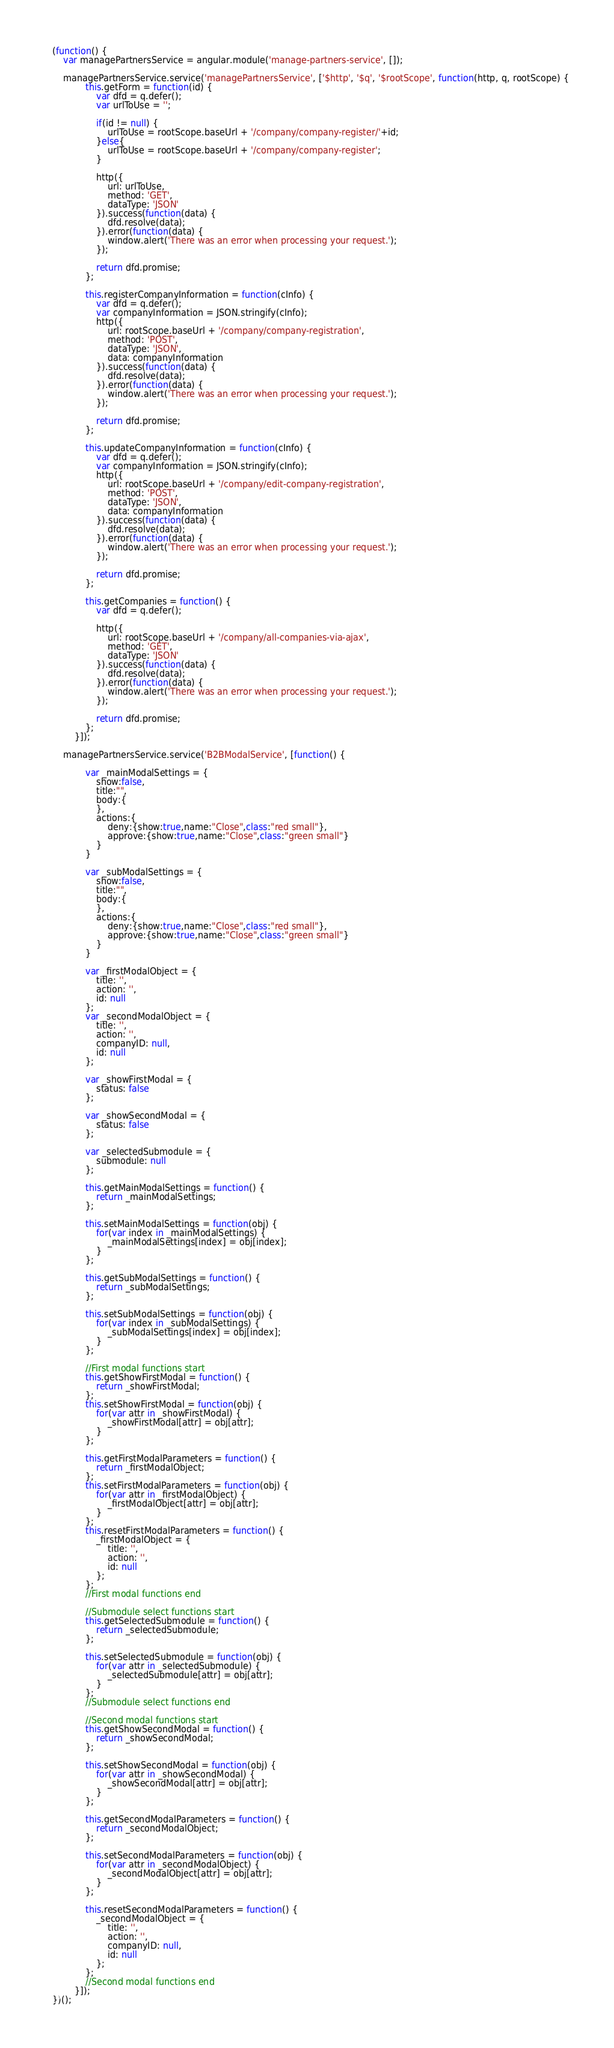Convert code to text. <code><loc_0><loc_0><loc_500><loc_500><_JavaScript_>(function() {
    var managePartnersService = angular.module('manage-partners-service', []);

    managePartnersService.service('managePartnersService', ['$http', '$q', '$rootScope', function(http, q, rootScope) {
            this.getForm = function(id) {
                var dfd = q.defer();
                var urlToUse = '';
                
                if(id != null) {
                    urlToUse = rootScope.baseUrl + '/company/company-register/'+id;
                }else{
                    urlToUse = rootScope.baseUrl + '/company/company-register';
                }
                
                http({
                    url: urlToUse,
                    method: 'GET',
                    dataType: 'JSON'
                }).success(function(data) {
                    dfd.resolve(data);
                }).error(function(data) {
                    window.alert('There was an error when processing your request.');
                });

                return dfd.promise;
            };
            
            this.registerCompanyInformation = function(cInfo) {
                var dfd = q.defer();
                var companyInformation = JSON.stringify(cInfo);
                http({
                    url: rootScope.baseUrl + '/company/company-registration',
                    method: 'POST',
                    dataType: 'JSON',
                    data: companyInformation
                }).success(function(data) {
                    dfd.resolve(data);
                }).error(function(data) {
                    window.alert('There was an error when processing your request.');
                });

                return dfd.promise;
            };
            
            this.updateCompanyInformation = function(cInfo) {
                var dfd = q.defer();
                var companyInformation = JSON.stringify(cInfo);
                http({
                    url: rootScope.baseUrl + '/company/edit-company-registration',
                    method: 'POST',
                    dataType: 'JSON',
                    data: companyInformation
                }).success(function(data) {
                    dfd.resolve(data);
                }).error(function(data) {
                    window.alert('There was an error when processing your request.');
                });

                return dfd.promise;
            };
            
            this.getCompanies = function() {
                var dfd = q.defer();
                
                http({
                    url: rootScope.baseUrl + '/company/all-companies-via-ajax',
                    method: 'GET',
                    dataType: 'JSON'
                }).success(function(data) {
                    dfd.resolve(data);
                }).error(function(data) {
                    window.alert('There was an error when processing your request.');
                });

                return dfd.promise;
            };
        }]);

    managePartnersService.service('B2BModalService', [function() {

            var _mainModalSettings = {
                show:false,
                title:"",
                body:{
                },
                actions:{
                    deny:{show:true,name:"Close",class:"red small"},
                    approve:{show:true,name:"Close",class:"green small"}
                }
            }

            var _subModalSettings = {
                show:false,
                title:"",
                body:{
                },
                actions:{
                    deny:{show:true,name:"Close",class:"red small"},
                    approve:{show:true,name:"Close",class:"green small"}
                }
            }

            var _firstModalObject = {
                title: '',
                action: '',
                id: null
            };
            var _secondModalObject = {
                title: '',
                action: '',
                companyID: null,
                id: null
            };

            var _showFirstModal = {
                status: false
            };

            var _showSecondModal = {
                status: false
            };

            var _selectedSubmodule = {
                submodule: null
            };

            this.getMainModalSettings = function() {
                return _mainModalSettings;    
            };
            
            this.setMainModalSettings = function(obj) {
                for(var index in _mainModalSettings) {
                    _mainModalSettings[index] = obj[index];
                }
            };

            this.getSubModalSettings = function() {
                return _subModalSettings;    
            };
            
            this.setSubModalSettings = function(obj) {
                for(var index in _subModalSettings) {
                    _subModalSettings[index] = obj[index];
                }
            };

            //First modal functions start
            this.getShowFirstModal = function() {
                return _showFirstModal;    
            };
            this.setShowFirstModal = function(obj) {
                for(var attr in _showFirstModal) {
                    _showFirstModal[attr] = obj[attr];
                }
            };

            this.getFirstModalParameters = function() {
                return _firstModalObject;
            };
            this.setFirstModalParameters = function(obj) {
                for(var attr in _firstModalObject) {
                    _firstModalObject[attr] = obj[attr];
                }
            };
            this.resetFirstModalParameters = function() {
                _firstModalObject = {
                    title: '',
                    action: '',
                    id: null
                };
            };
            //First modal functions end

            //Submodule select functions start
            this.getSelectedSubmodule = function() {
                return _selectedSubmodule;
            };

            this.setSelectedSubmodule = function(obj) {
                for(var attr in _selectedSubmodule) {
                    _selectedSubmodule[attr] = obj[attr];
                }
            };
            //Submodule select functions end

            //Second modal functions start
            this.getShowSecondModal = function() {
                return _showSecondModal;
            };

            this.setShowSecondModal = function(obj) {
                for(var attr in _showSecondModal) {
                    _showSecondModal[attr] = obj[attr];
                }
            };
            
            this.getSecondModalParameters = function() {
                return _secondModalObject;
            };

            this.setSecondModalParameters = function(obj) {
                for(var attr in _secondModalObject) {
                    _secondModalObject[attr] = obj[attr];
                }
            };

            this.resetSecondModalParameters = function() {
                _secondModalObject = {
                    title: '',
                    action: '',
                    companyID: null,
                    id: null
                };
            };
            //Second modal functions end
        }]);
})();</code> 